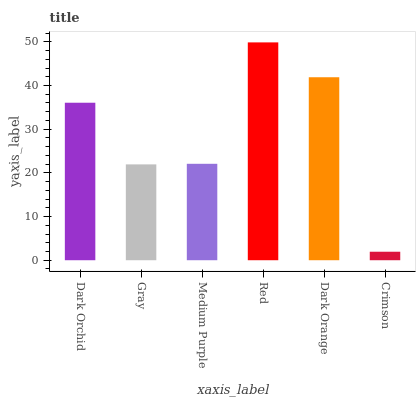Is Crimson the minimum?
Answer yes or no. Yes. Is Red the maximum?
Answer yes or no. Yes. Is Gray the minimum?
Answer yes or no. No. Is Gray the maximum?
Answer yes or no. No. Is Dark Orchid greater than Gray?
Answer yes or no. Yes. Is Gray less than Dark Orchid?
Answer yes or no. Yes. Is Gray greater than Dark Orchid?
Answer yes or no. No. Is Dark Orchid less than Gray?
Answer yes or no. No. Is Dark Orchid the high median?
Answer yes or no. Yes. Is Medium Purple the low median?
Answer yes or no. Yes. Is Medium Purple the high median?
Answer yes or no. No. Is Red the low median?
Answer yes or no. No. 